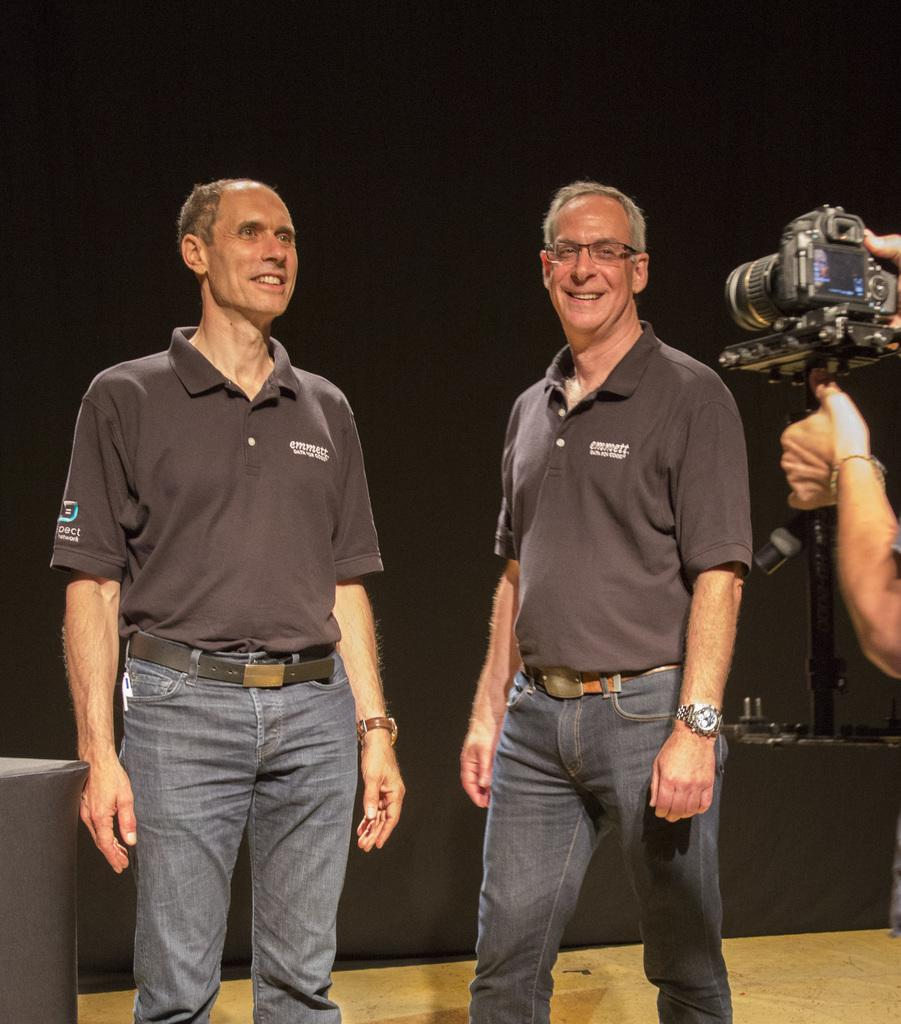How many people are in the image? There are three persons in the image. What are the positions of the two standing persons? Two of the persons are standing. What expressions do the standing persons have? The two standing persons are smiling. What is one person holding in the image? One person is holding a camera. What type of snails can be seen crawling on the camera in the image? There are no snails present in the image, and the camera is not being crawled on by any snails. 